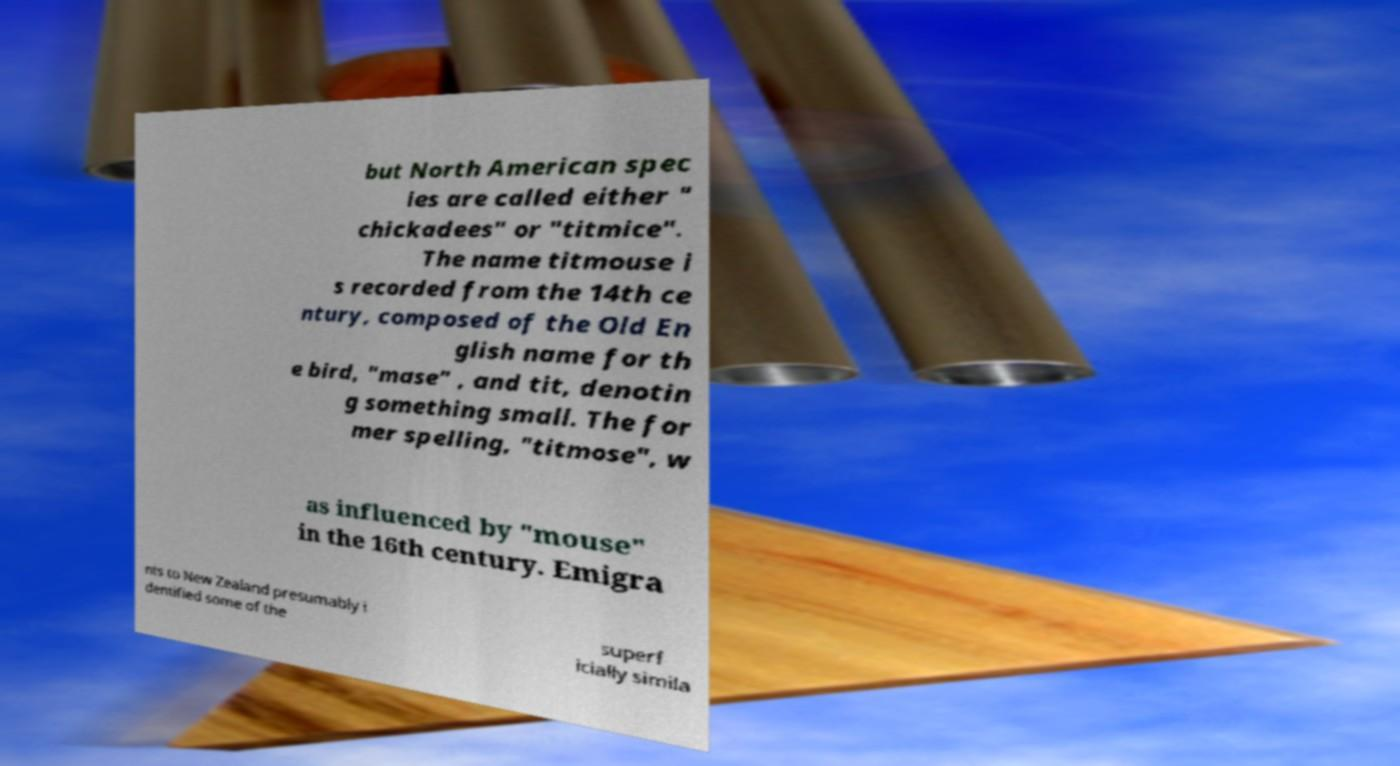Could you extract and type out the text from this image? but North American spec ies are called either " chickadees" or "titmice". The name titmouse i s recorded from the 14th ce ntury, composed of the Old En glish name for th e bird, "mase" , and tit, denotin g something small. The for mer spelling, "titmose", w as influenced by "mouse" in the 16th century. Emigra nts to New Zealand presumably i dentified some of the superf icially simila 